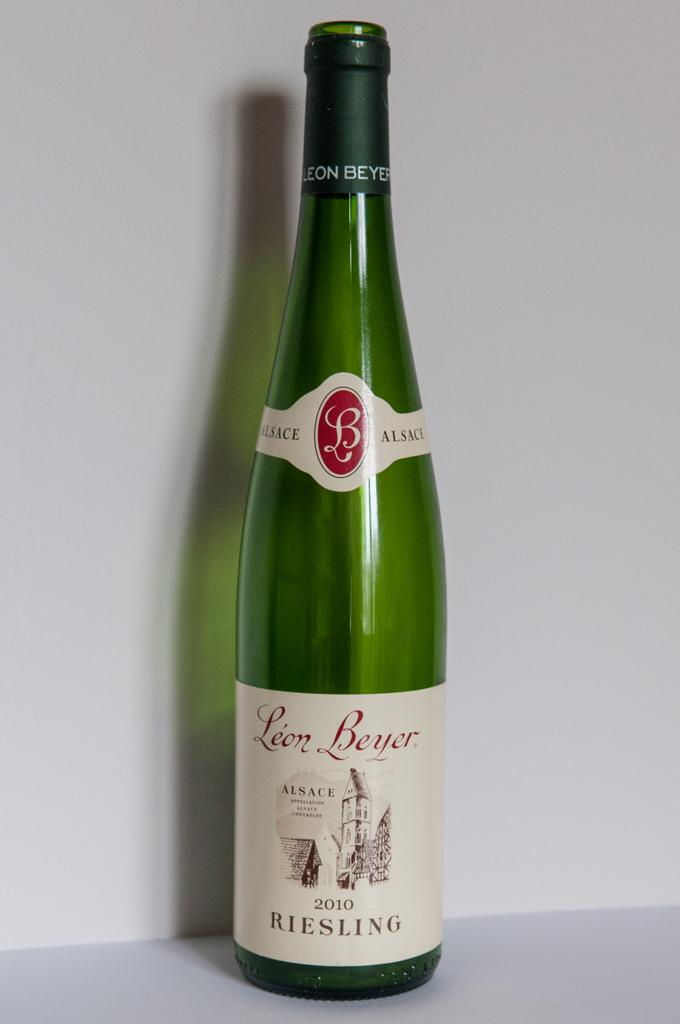Provide a one-sentence caption for the provided image. The bottle of white Riesling wine was created in 2010. 